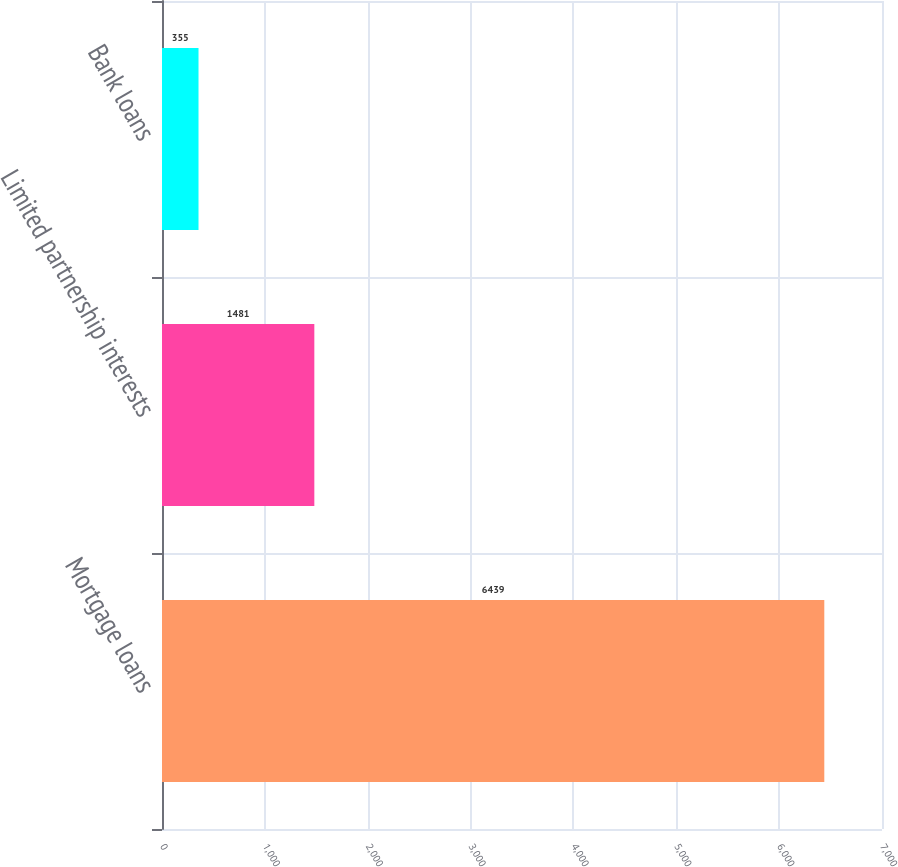<chart> <loc_0><loc_0><loc_500><loc_500><bar_chart><fcel>Mortgage loans<fcel>Limited partnership interests<fcel>Bank loans<nl><fcel>6439<fcel>1481<fcel>355<nl></chart> 